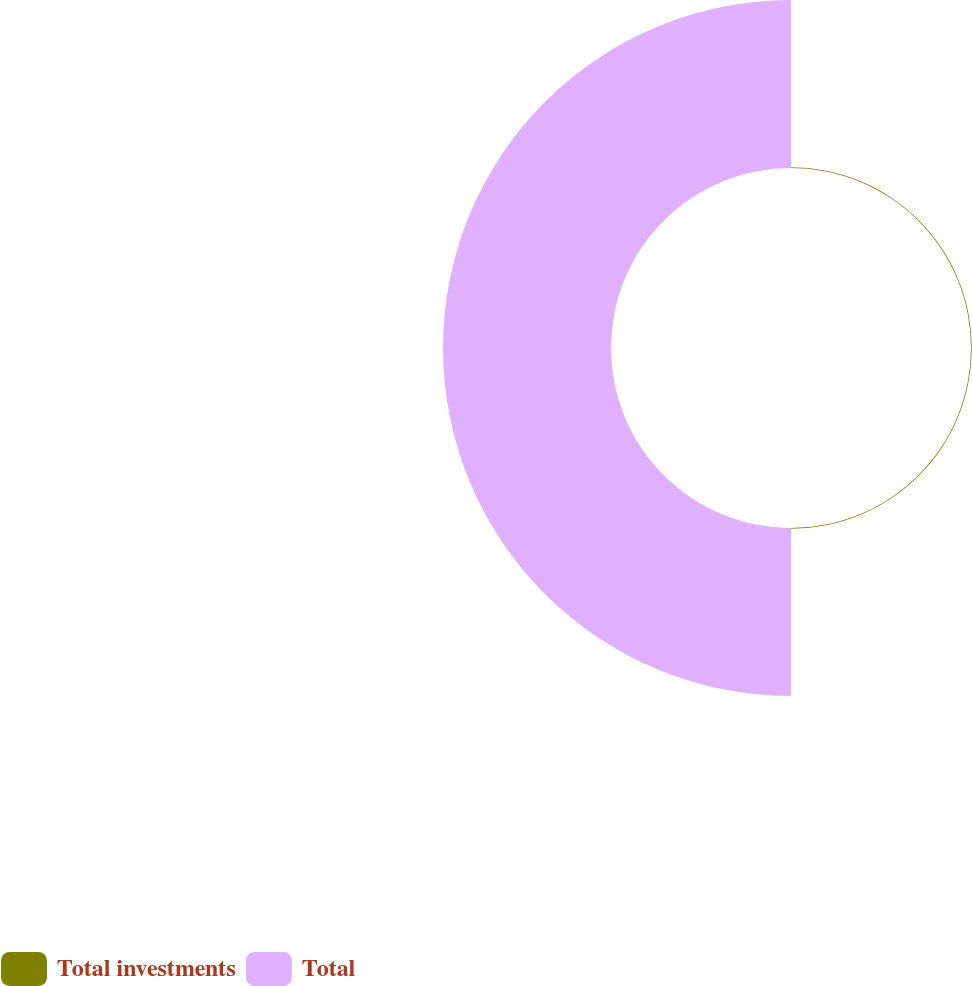Convert chart. <chart><loc_0><loc_0><loc_500><loc_500><pie_chart><fcel>Total investments<fcel>Total<nl><fcel>0.45%<fcel>99.55%<nl></chart> 